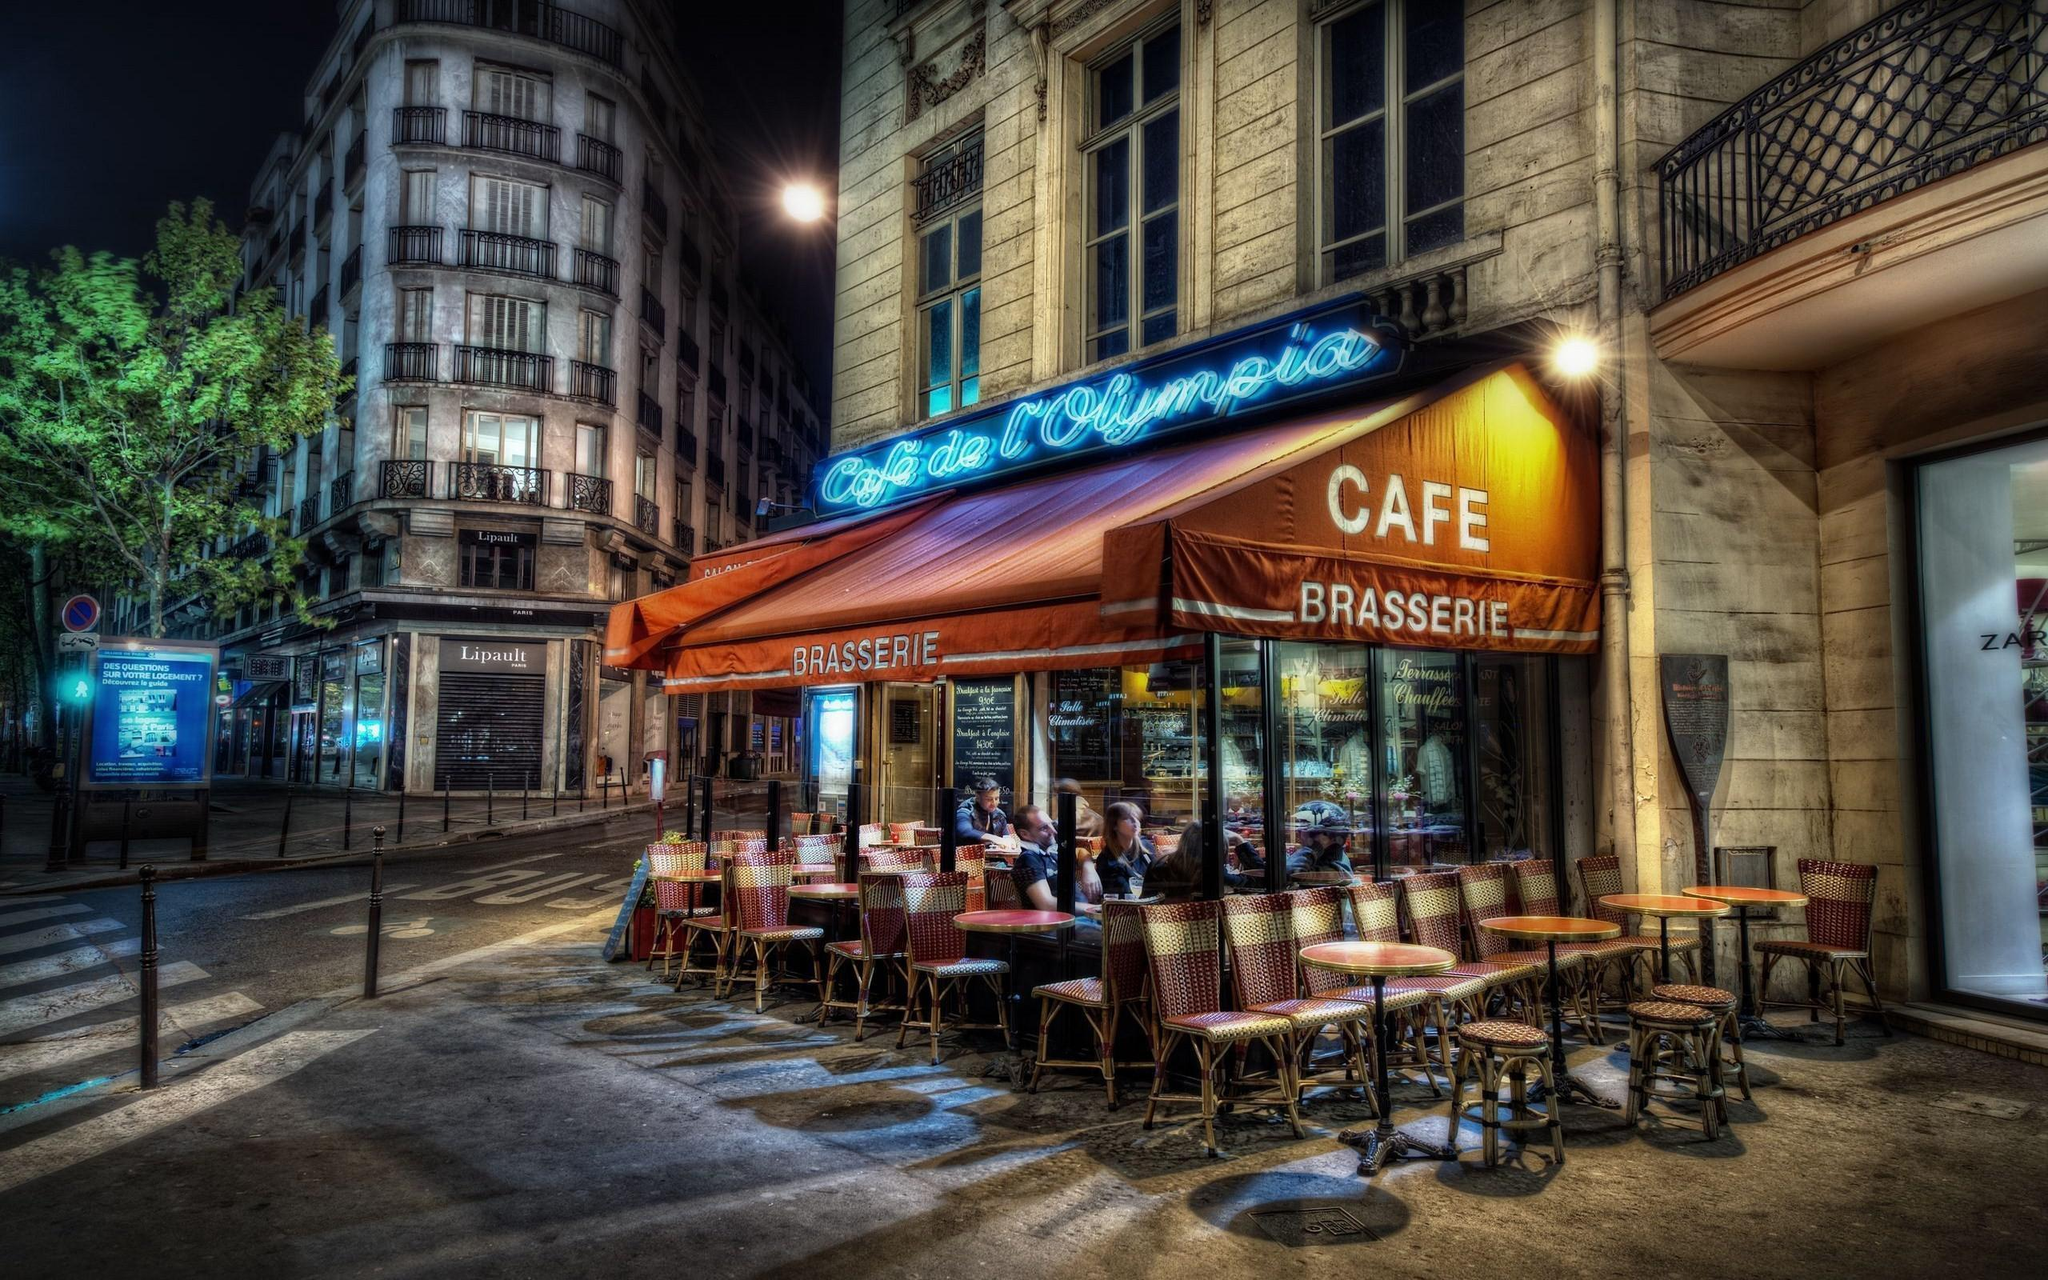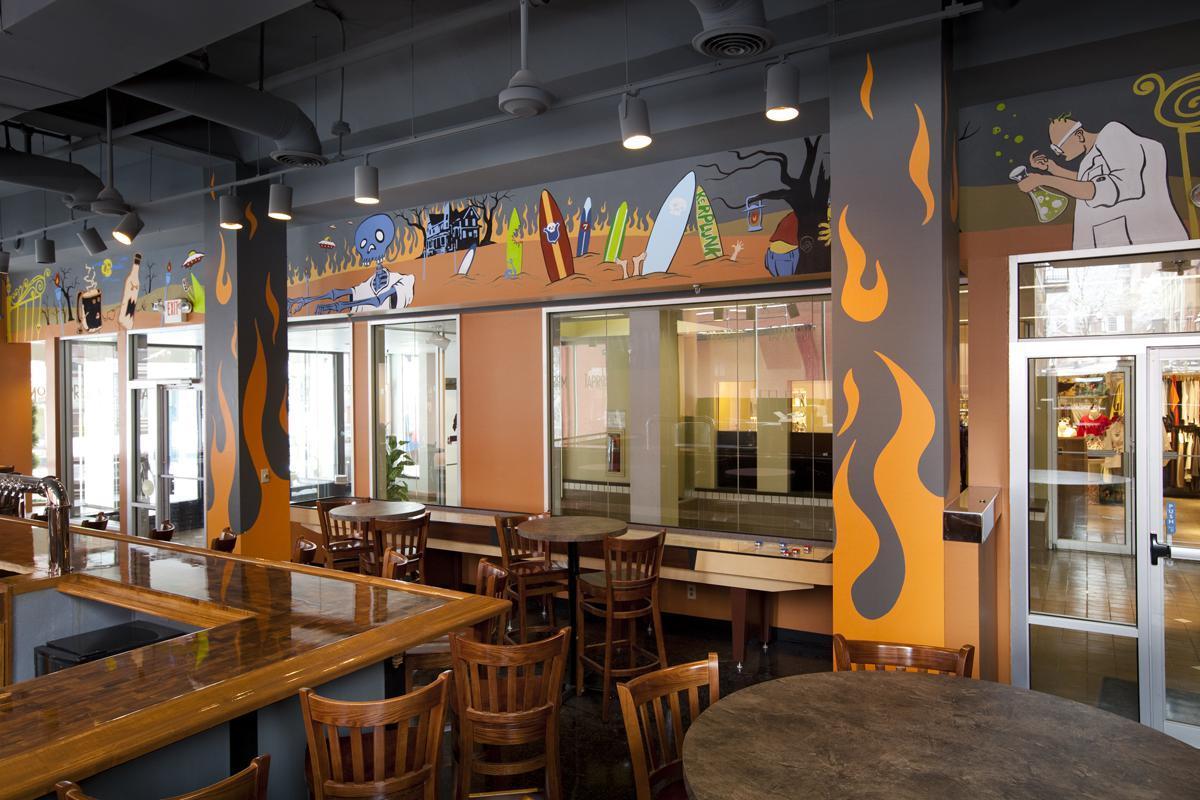The first image is the image on the left, the second image is the image on the right. Given the left and right images, does the statement "People are standing at the counter of the restaurant in one of the images." hold true? Answer yes or no. No. The first image is the image on the left, the second image is the image on the right. For the images shown, is this caption "One image has windows and the other does not." true? Answer yes or no. No. 